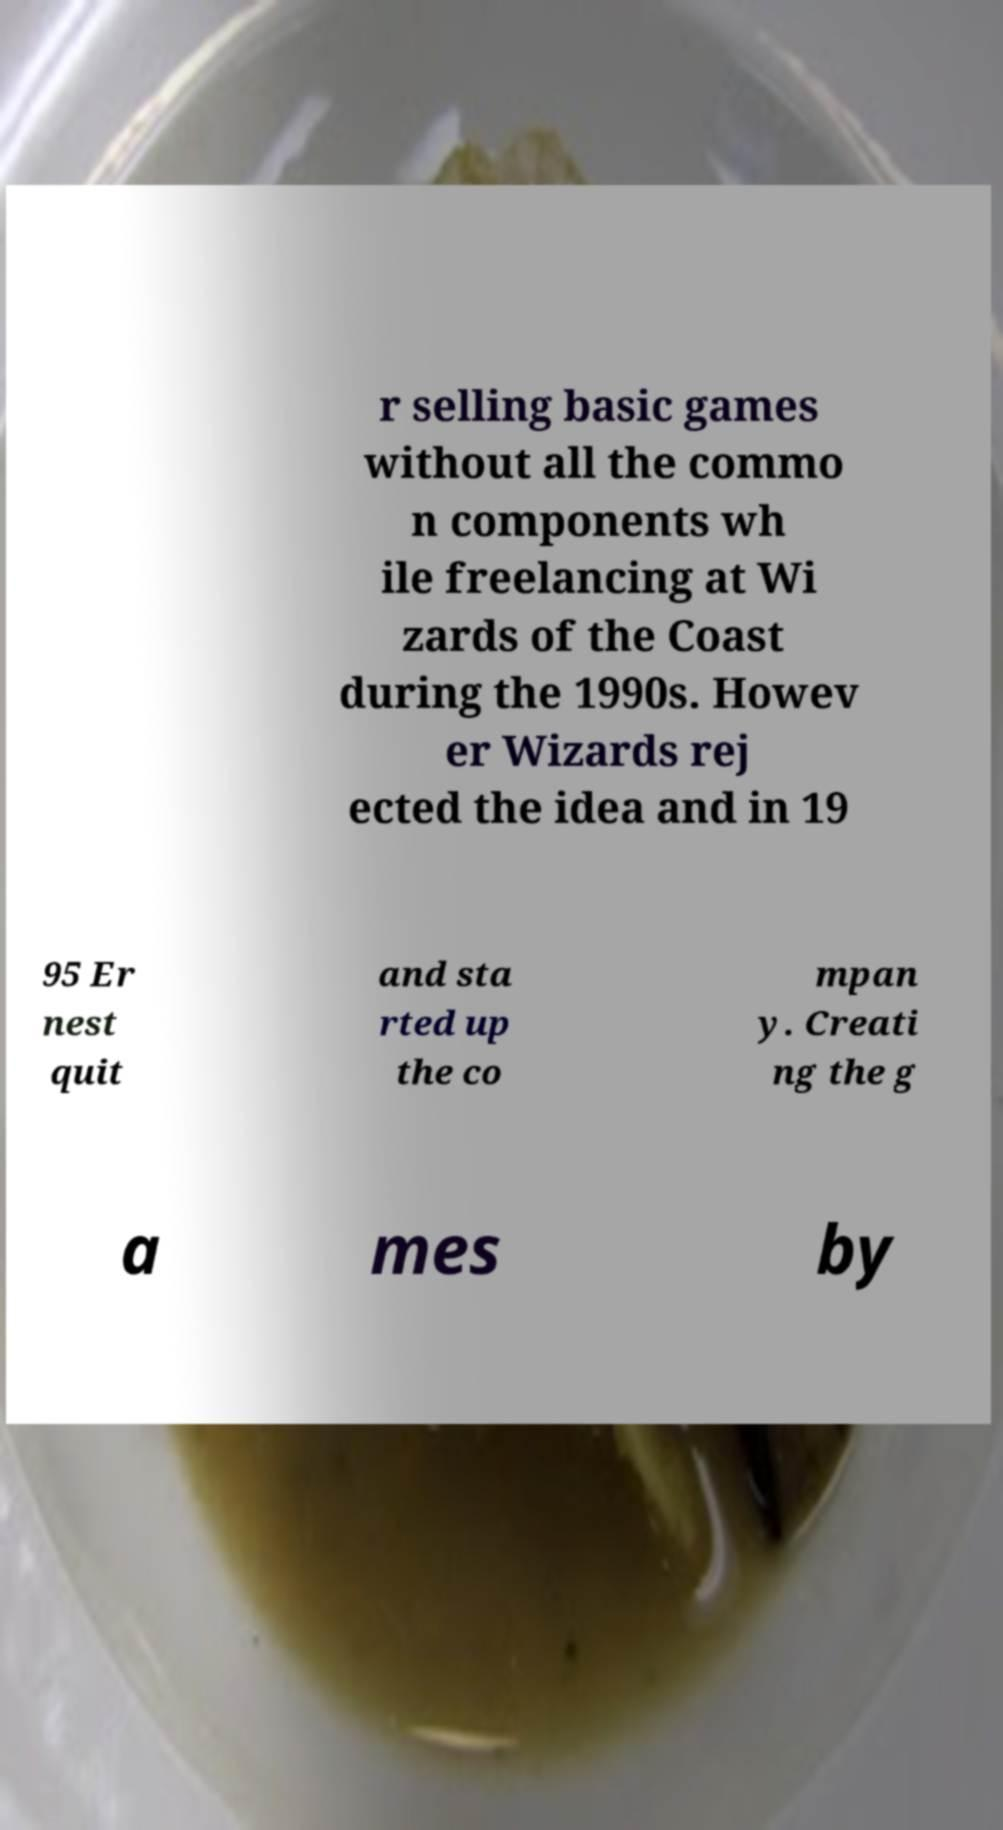Could you assist in decoding the text presented in this image and type it out clearly? r selling basic games without all the commo n components wh ile freelancing at Wi zards of the Coast during the 1990s. Howev er Wizards rej ected the idea and in 19 95 Er nest quit and sta rted up the co mpan y. Creati ng the g a mes by 